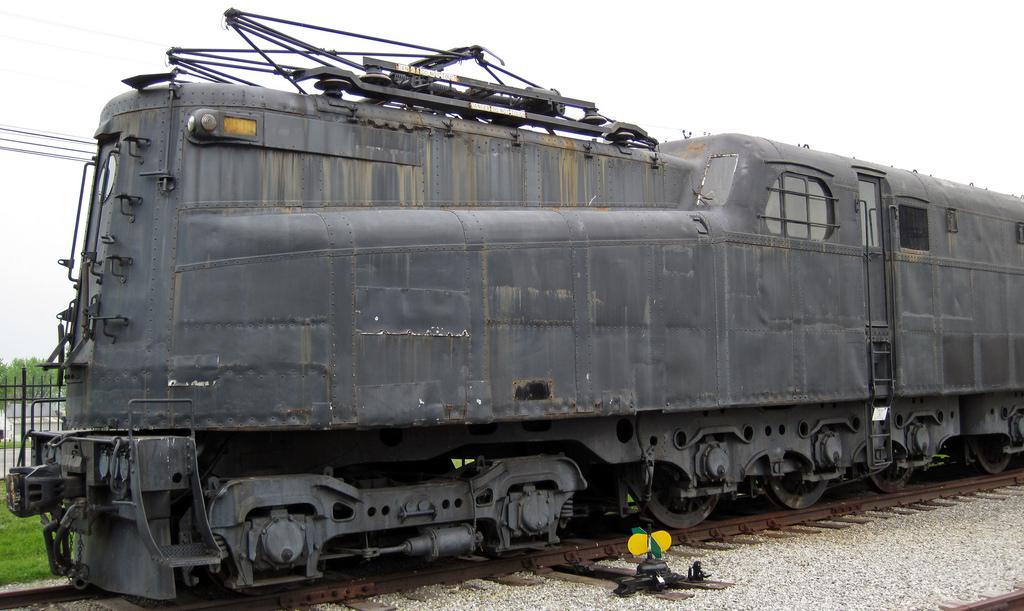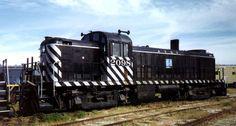The first image is the image on the left, the second image is the image on the right. Assess this claim about the two images: "The image on the right contains a vehicle with black and white stripes.". Correct or not? Answer yes or no. Yes. 